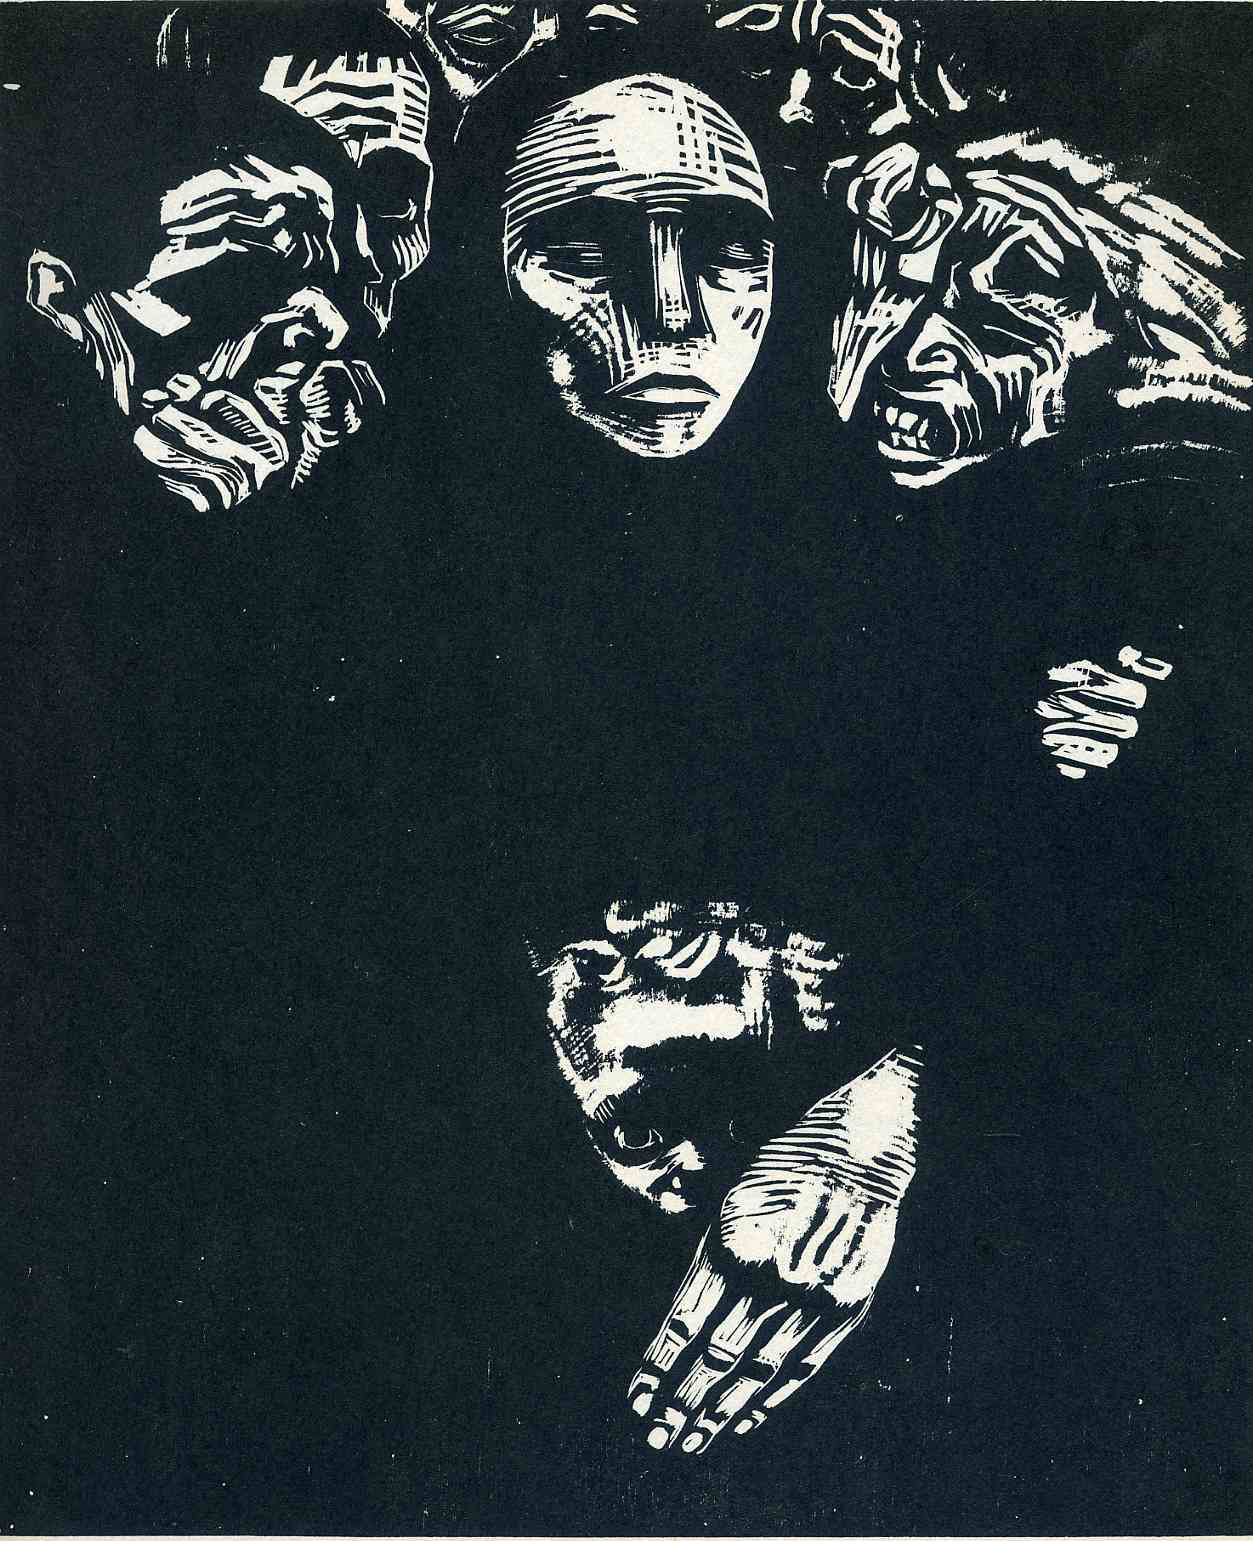Can you elaborate on the elements of the picture provided? The image features a stark black and white composition, primarily utilizing strong contrasts and bold lines typical of a woodcut printing technique. At its core is a prominent face, expression neutral yet compelling, which is encircled by smaller, distorted faces that seem to emerge from the darkness, creating a haunting, almost ghostly effect. These faces could represent different facets of a personality or various voices in a societal or psychological dialogue. Below this assembly, hands reach upward, evoking a desperate yearning or the striving for connection or understanding. The artwork's surrealistic approach invites viewers to explore themes of identity, human emotion, and the complexity of human interactions. 